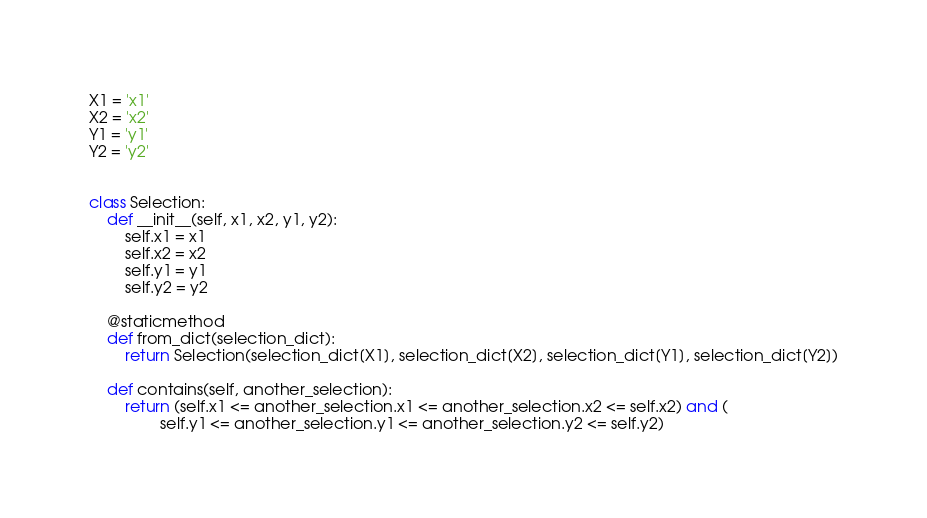<code> <loc_0><loc_0><loc_500><loc_500><_Python_>X1 = 'x1'
X2 = 'x2'
Y1 = 'y1'
Y2 = 'y2'


class Selection:
    def __init__(self, x1, x2, y1, y2):
        self.x1 = x1
        self.x2 = x2
        self.y1 = y1
        self.y2 = y2

    @staticmethod
    def from_dict(selection_dict):
        return Selection(selection_dict[X1], selection_dict[X2], selection_dict[Y1], selection_dict[Y2])

    def contains(self, another_selection):
        return (self.x1 <= another_selection.x1 <= another_selection.x2 <= self.x2) and (
                self.y1 <= another_selection.y1 <= another_selection.y2 <= self.y2)
</code> 